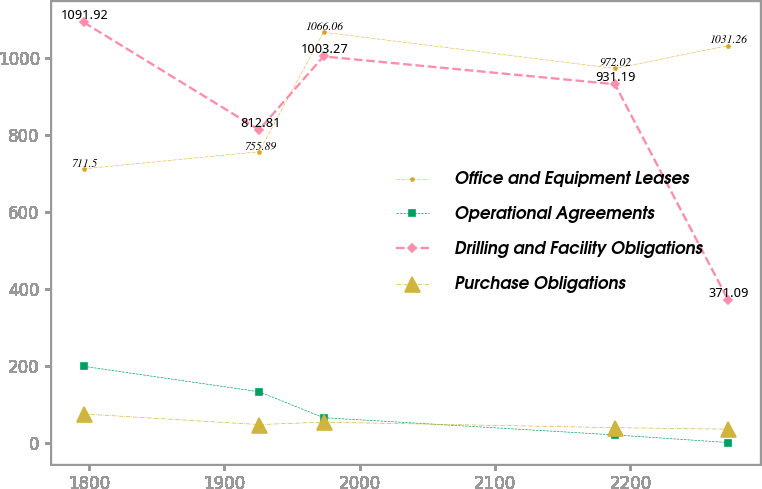Convert chart. <chart><loc_0><loc_0><loc_500><loc_500><line_chart><ecel><fcel>Office and Equipment Leases<fcel>Operational Agreements<fcel>Drilling and Facility Obligations<fcel>Purchase Obligations<nl><fcel>1796.01<fcel>711.5<fcel>198.84<fcel>1091.92<fcel>75.03<nl><fcel>1925.63<fcel>755.89<fcel>132.72<fcel>812.81<fcel>47.57<nl><fcel>1973.25<fcel>1066.06<fcel>65.44<fcel>1003.27<fcel>53.84<nl><fcel>2188.53<fcel>972.02<fcel>20.7<fcel>931.19<fcel>39.52<nl><fcel>2272.2<fcel>1031.26<fcel>0.91<fcel>371.09<fcel>35.57<nl></chart> 